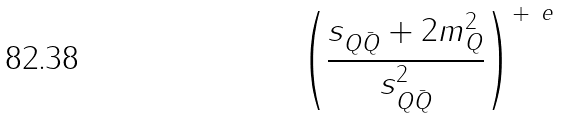Convert formula to latex. <formula><loc_0><loc_0><loc_500><loc_500>\left ( \frac { s _ { Q \bar { Q } } + 2 m _ { Q } ^ { 2 } } { s _ { Q \bar { Q } } ^ { 2 } } \right ) ^ { + \ e }</formula> 